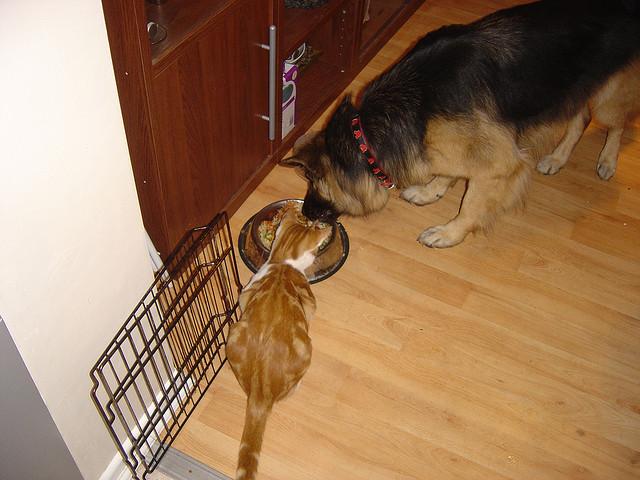Where is the dog?
Give a very brief answer. Next to cat. Are the dogs being transported somewhere?
Be succinct. No. Are the animals sharing?
Concise answer only. Yes. Are they eating dog food?
Answer briefly. Yes. Is one of the animals larger than the other?
Concise answer only. Yes. 